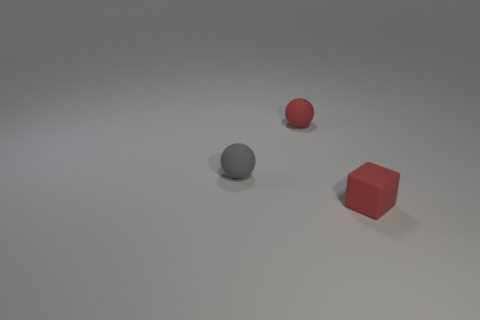Add 1 small gray spheres. How many objects exist? 4 Subtract all cubes. How many objects are left? 2 Add 1 small gray things. How many small gray things are left? 2 Add 1 red spheres. How many red spheres exist? 2 Subtract 0 brown cylinders. How many objects are left? 3 Subtract all tiny green metal cubes. Subtract all gray balls. How many objects are left? 2 